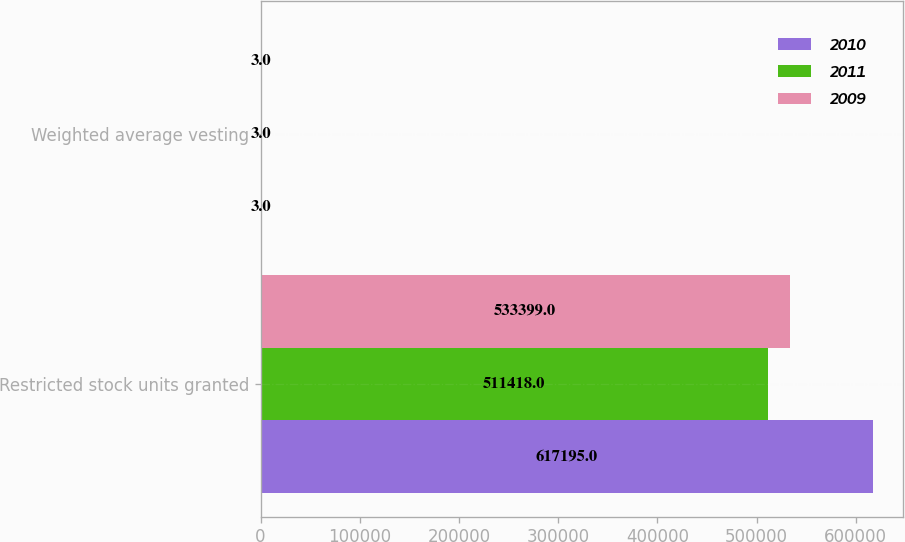Convert chart to OTSL. <chart><loc_0><loc_0><loc_500><loc_500><stacked_bar_chart><ecel><fcel>Restricted stock units granted<fcel>Weighted average vesting<nl><fcel>2010<fcel>617195<fcel>3<nl><fcel>2011<fcel>511418<fcel>3<nl><fcel>2009<fcel>533399<fcel>3<nl></chart> 